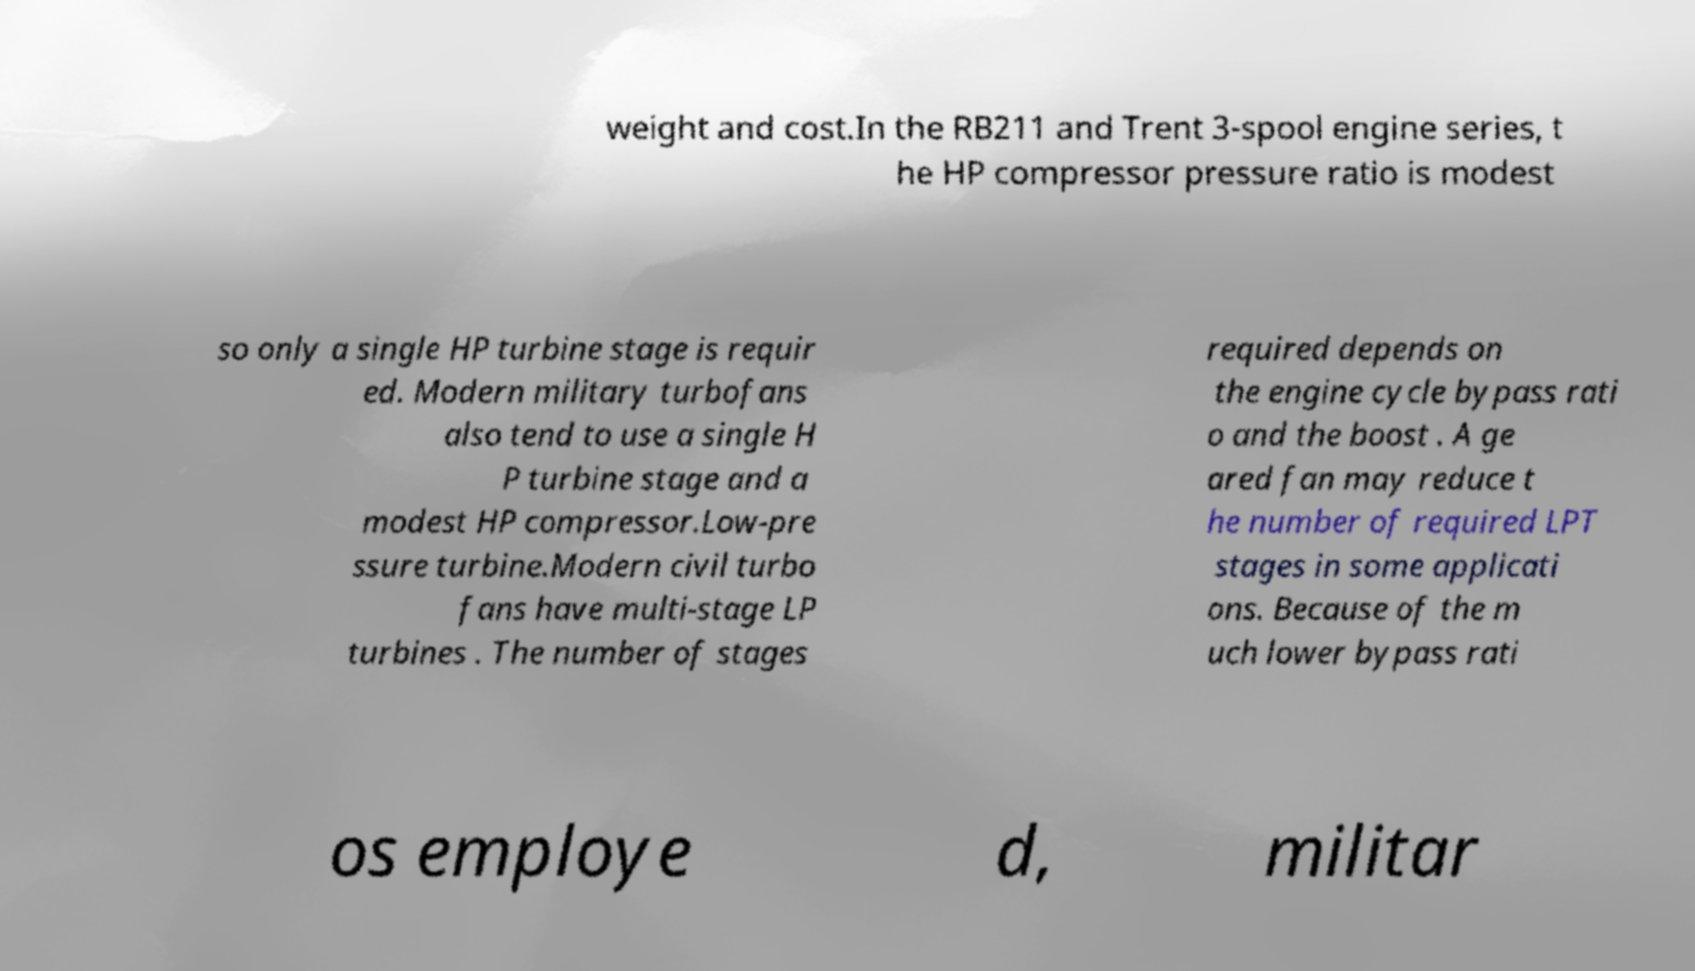For documentation purposes, I need the text within this image transcribed. Could you provide that? weight and cost.In the RB211 and Trent 3-spool engine series, t he HP compressor pressure ratio is modest so only a single HP turbine stage is requir ed. Modern military turbofans also tend to use a single H P turbine stage and a modest HP compressor.Low-pre ssure turbine.Modern civil turbo fans have multi-stage LP turbines . The number of stages required depends on the engine cycle bypass rati o and the boost . A ge ared fan may reduce t he number of required LPT stages in some applicati ons. Because of the m uch lower bypass rati os employe d, militar 